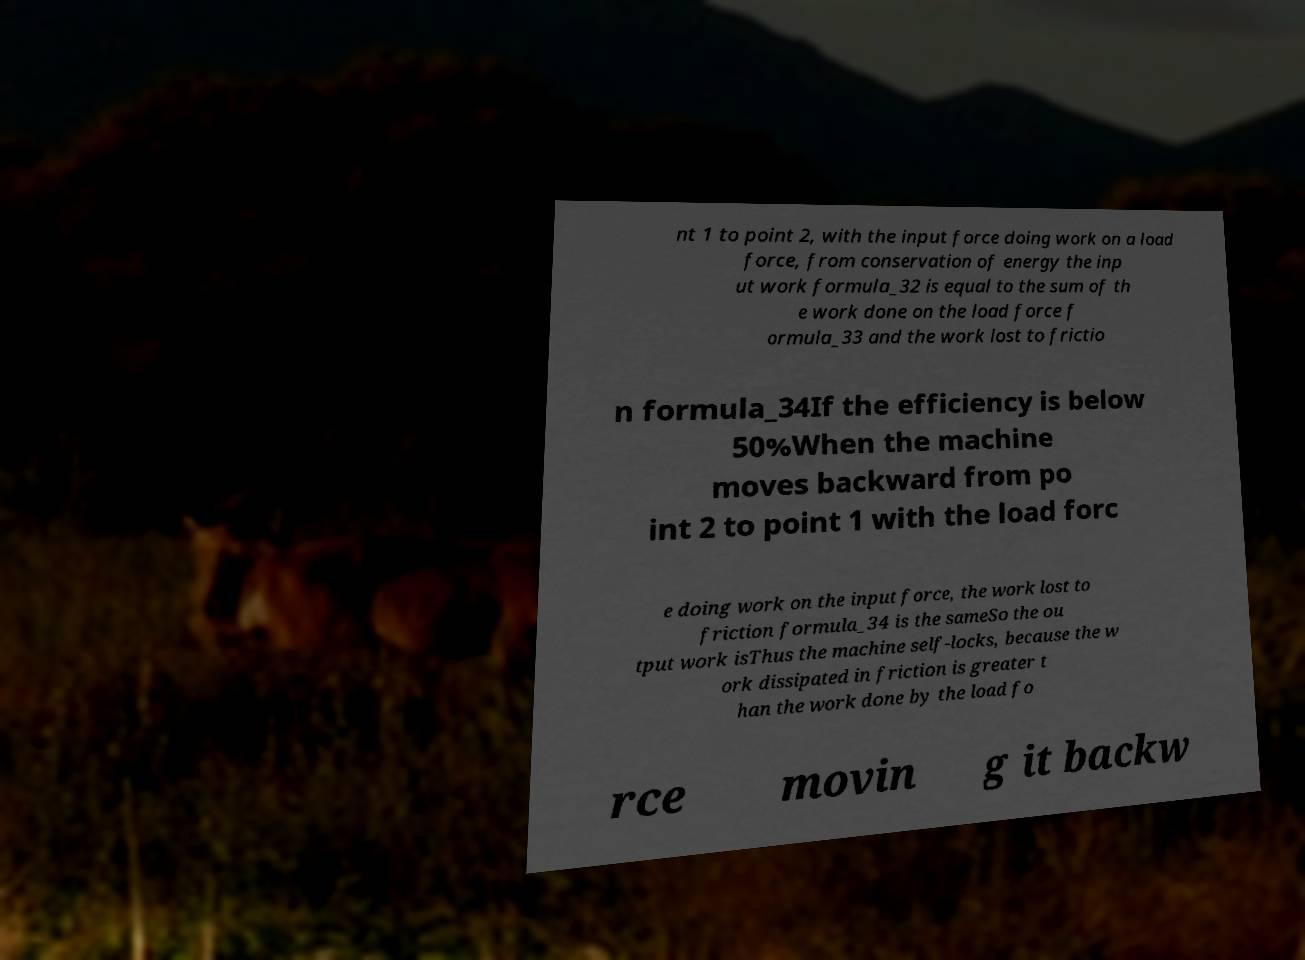For documentation purposes, I need the text within this image transcribed. Could you provide that? nt 1 to point 2, with the input force doing work on a load force, from conservation of energy the inp ut work formula_32 is equal to the sum of th e work done on the load force f ormula_33 and the work lost to frictio n formula_34If the efficiency is below 50%When the machine moves backward from po int 2 to point 1 with the load forc e doing work on the input force, the work lost to friction formula_34 is the sameSo the ou tput work isThus the machine self-locks, because the w ork dissipated in friction is greater t han the work done by the load fo rce movin g it backw 